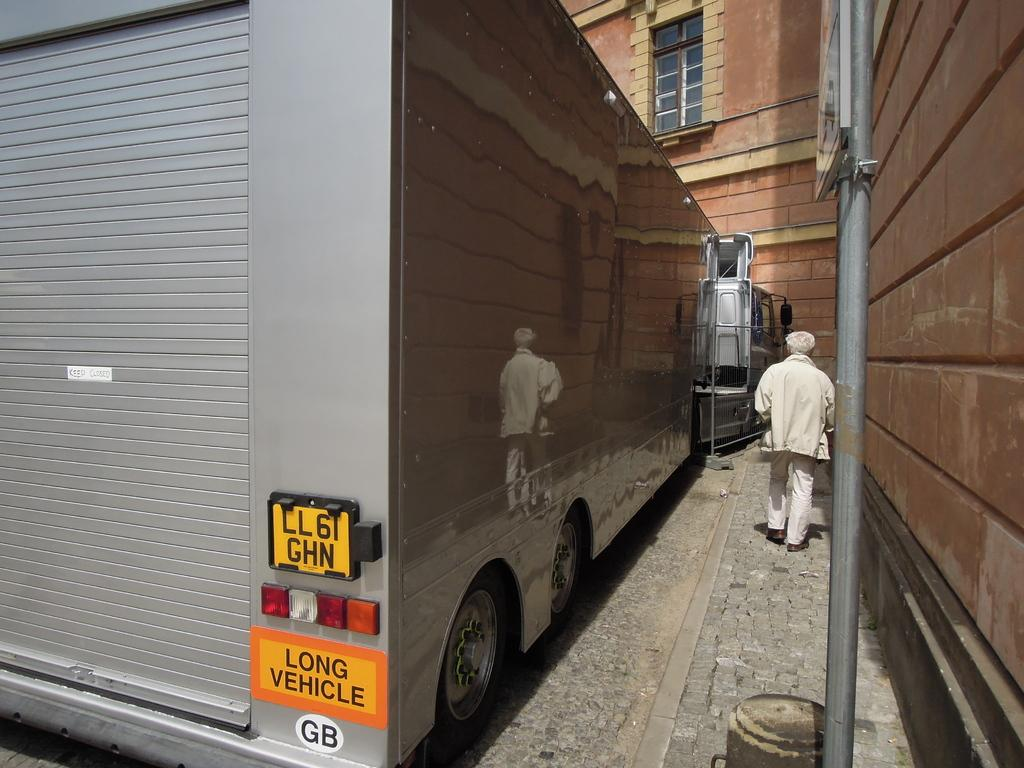What type of vehicle is in the image? There is a long vehicle in the image. Who or what is in the middle of the vehicle? There is a person in the middle of the vehicle. What is in the middle of the vehicle along with the person? There is a pole in the middle of the vehicle. What is attached to the pole? There is a board attached to the pole. What can be seen in the background of the image? There is a building in the background of the image. How long does it take for the person to have a minute thought in the image? There is no information about the person's thoughts in the image, so it is impossible to determine how long it takes for them to have a minute thought. 